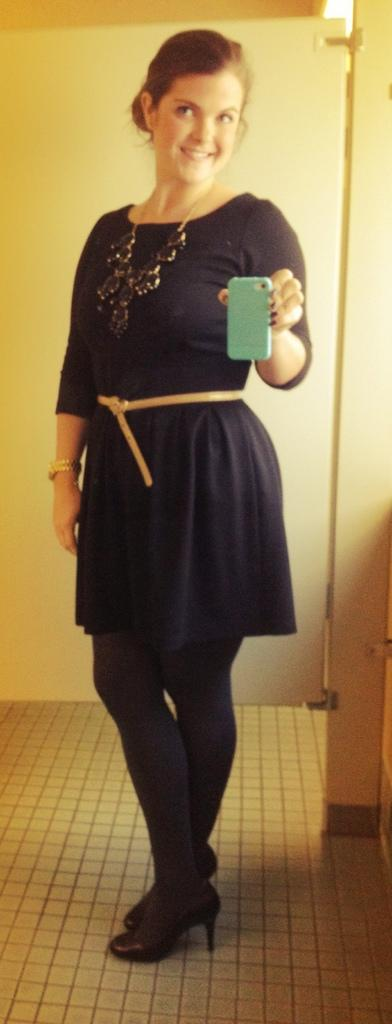Who is present in the image? There is a woman in the image. What is the woman doing in the image? The woman is standing on the floor and holding a mobile. What can be seen in the background of the image? There is a door visible in the background of the image. What type of pen is the woman using to write a letter in the image? There is no pen or letter present in the image; the woman is holding a mobile. 